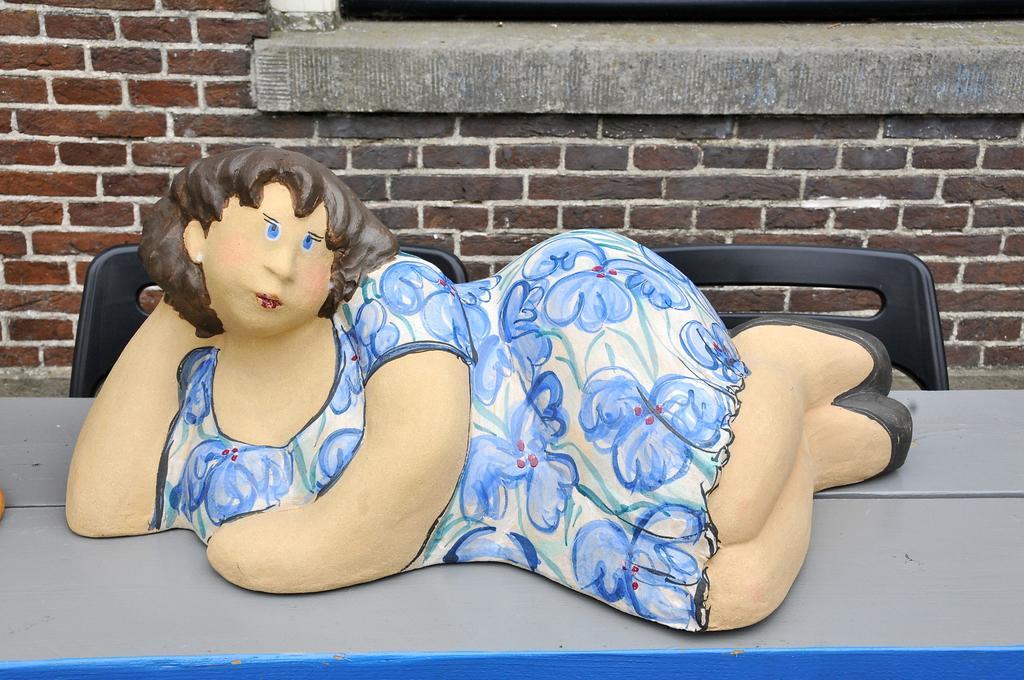Describe this image in one or two sentences. We can see statue of a woman on the table and we can see chairs. In the background we can see wall. 